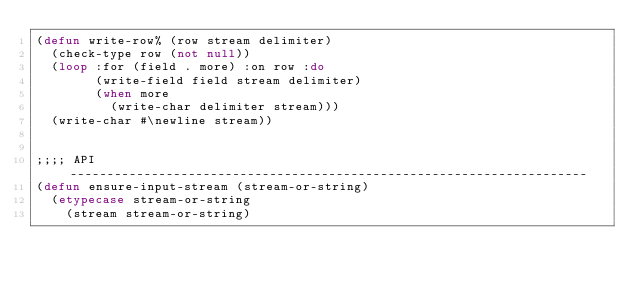Convert code to text. <code><loc_0><loc_0><loc_500><loc_500><_Lisp_>(defun write-row% (row stream delimiter)
  (check-type row (not null))
  (loop :for (field . more) :on row :do
        (write-field field stream delimiter)
        (when more
          (write-char delimiter stream)))
  (write-char #\newline stream))


;;;; API ----------------------------------------------------------------------
(defun ensure-input-stream (stream-or-string)
  (etypecase stream-or-string
    (stream stream-or-string)</code> 